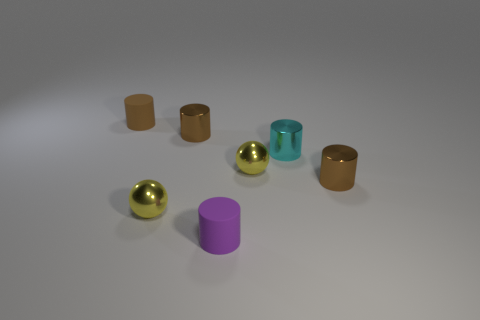There is a small metal sphere that is to the left of the purple matte thing; is it the same color as the small metal sphere that is right of the small purple rubber cylinder?
Your response must be concise. Yes. How many red rubber spheres are the same size as the brown rubber cylinder?
Make the answer very short. 0. How many tiny brown rubber things are on the left side of the small rubber cylinder that is behind the metal cylinder to the right of the cyan metallic object?
Offer a very short reply. 0. What number of small cylinders are behind the purple cylinder and in front of the small cyan shiny object?
Provide a short and direct response. 1. How many metal objects are either balls or tiny red spheres?
Your answer should be very brief. 2. There is a purple thing right of the brown metallic cylinder to the left of the small brown object that is to the right of the small cyan cylinder; what is its material?
Your response must be concise. Rubber. The small cylinder that is in front of the tiny shiny cylinder right of the cyan metal cylinder is made of what material?
Make the answer very short. Rubber. What number of large things are either cyan metallic things or yellow balls?
Your answer should be compact. 0. How many things are tiny shiny things in front of the tiny cyan metal cylinder or brown metallic cylinders?
Give a very brief answer. 4. What number of other things are the same shape as the purple thing?
Offer a terse response. 4. 